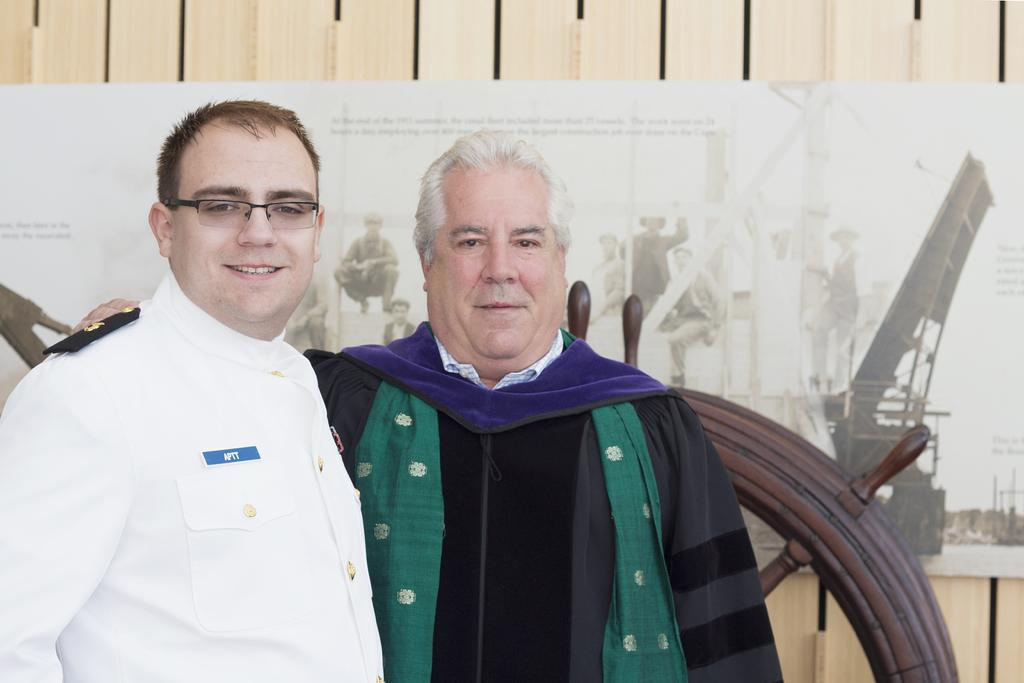Who is the main subject in the image? There is an old man in the image. What is the old man wearing? The old man is wearing a black dress. What can be observed about the old man's hair? The old man has white hair. Are there any other people in the image? Yes, there is a man in the image. What is the man wearing? The man is wearing a white dress. How are the old man and the man positioned in the image? The old man and the man are standing beside each other. What can be seen in the background of the image? There is a wall in the background of the image. What is on the wall? The wall has a wallpaper on it, and there is a wooden steering wheel on the wall. How many rays are visible in the image? There are no rays visible in the image. What type of paper is the old man holding in the image? The old man is not holding any paper in the image. 